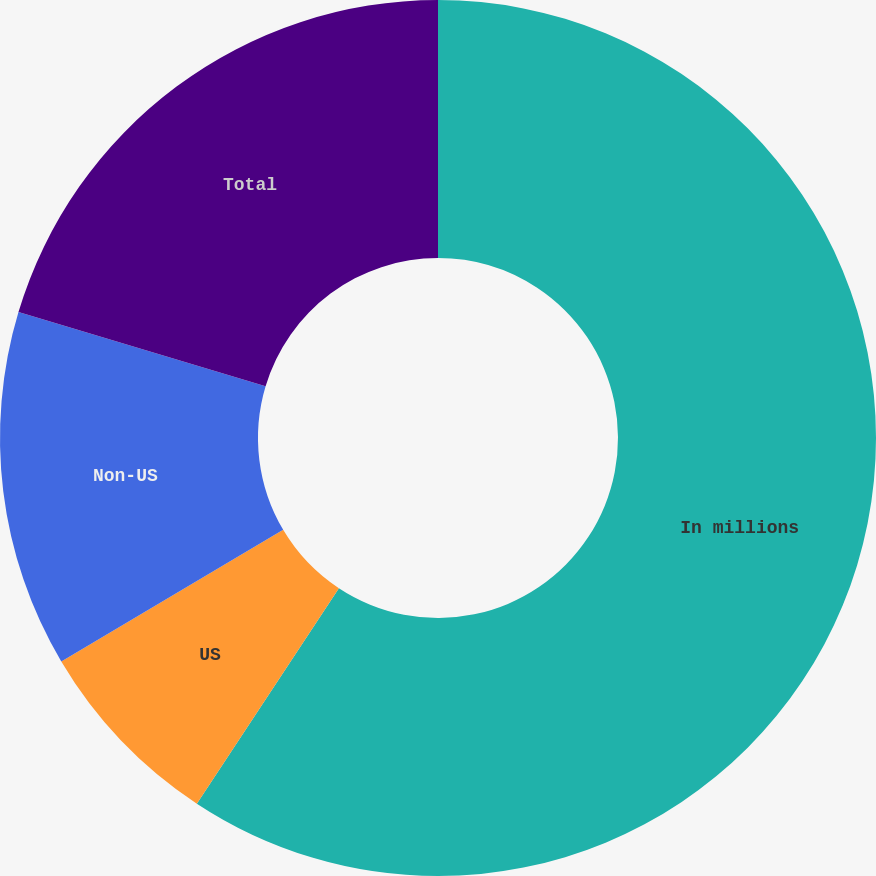Convert chart. <chart><loc_0><loc_0><loc_500><loc_500><pie_chart><fcel>In millions<fcel>US<fcel>Non-US<fcel>Total<nl><fcel>59.28%<fcel>7.2%<fcel>13.16%<fcel>20.36%<nl></chart> 